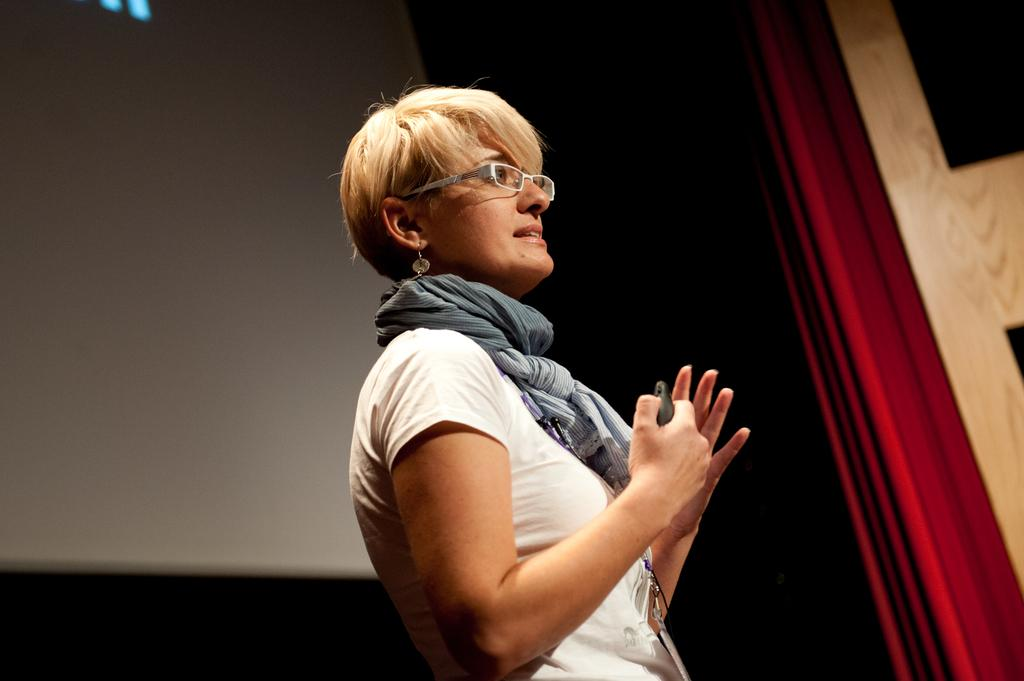What is the main subject of the image? The main subject of the image is a beautiful woman. What is the woman doing in the image? The woman is standing in the image. What is the woman wearing in the image? The woman is wearing a white dress in the image. What accessory is the woman wearing in the image? The woman is wearing spectacles in the image. What type of list is the woman holding in the image? There is no list present in the image; the woman is not holding anything. What class is the woman teaching in the image? There is no indication of a class or teaching activity in the image. 